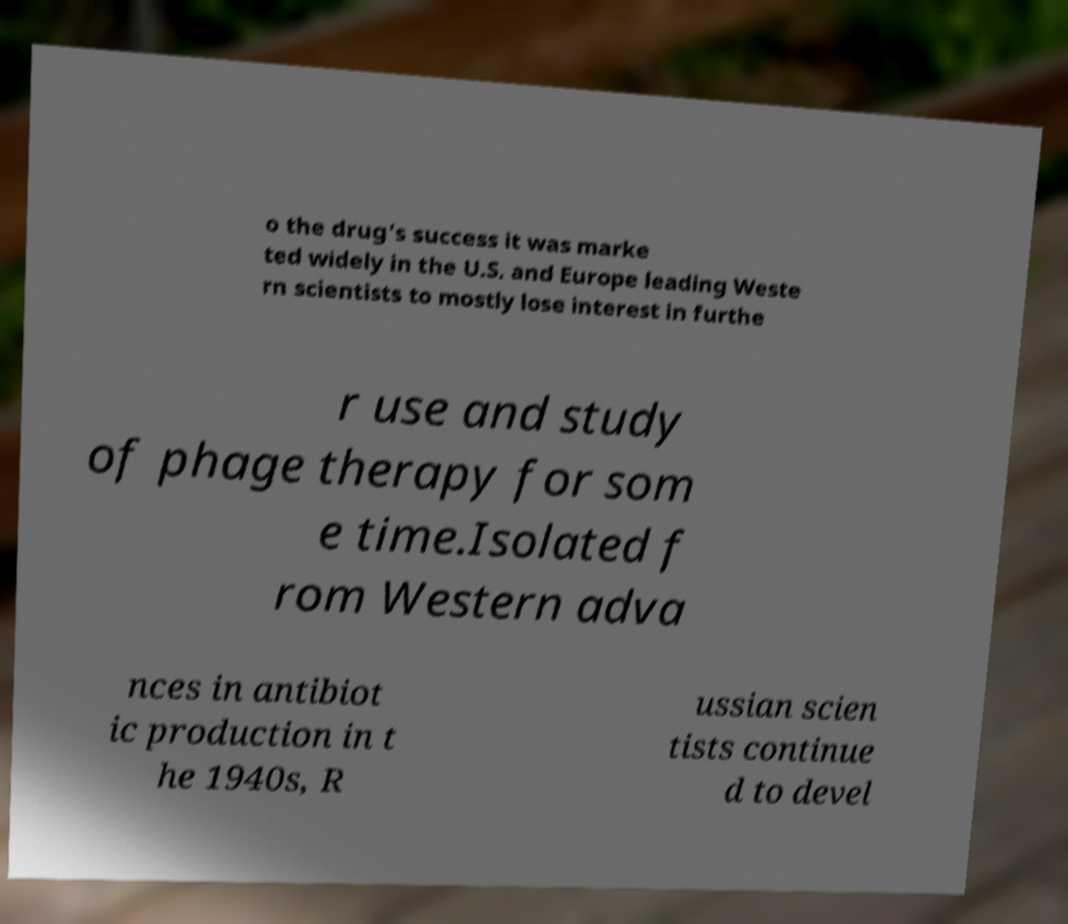Can you accurately transcribe the text from the provided image for me? o the drug's success it was marke ted widely in the U.S. and Europe leading Weste rn scientists to mostly lose interest in furthe r use and study of phage therapy for som e time.Isolated f rom Western adva nces in antibiot ic production in t he 1940s, R ussian scien tists continue d to devel 